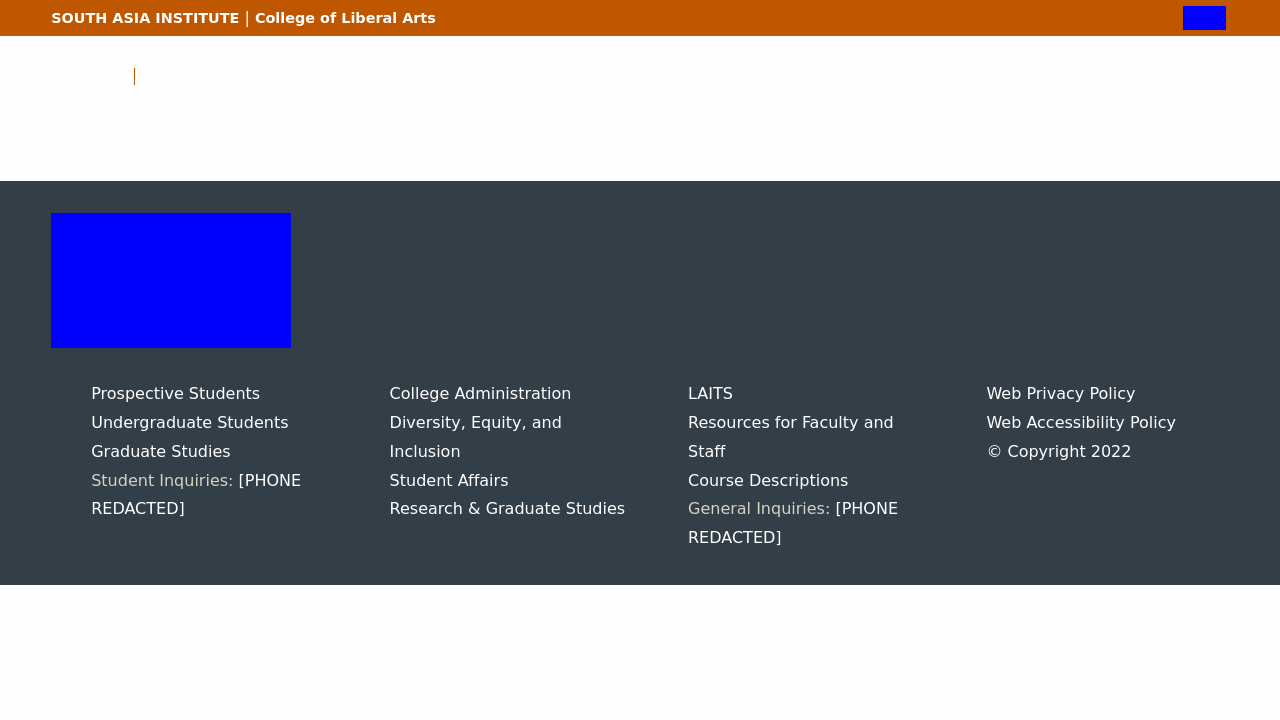Could you detail the process for assembling this website using HTML? Creating a website like the one shown in the image, involving sections for 'Prospective Students', 'College Administration', and other services, would start by structuring the HTML document with a basic template. This includes declaring the doctype and setting the head and body sections. Containers such as <div> tags would be used to organize content into blocks corresponding to different departments or areas. Each section could then be styled with CSS to ensure it aligns visually with the simple and clean layout seen in the image. Additional functionalities such as embedded contact information or links can be added using HTML forms or anchor tags. 